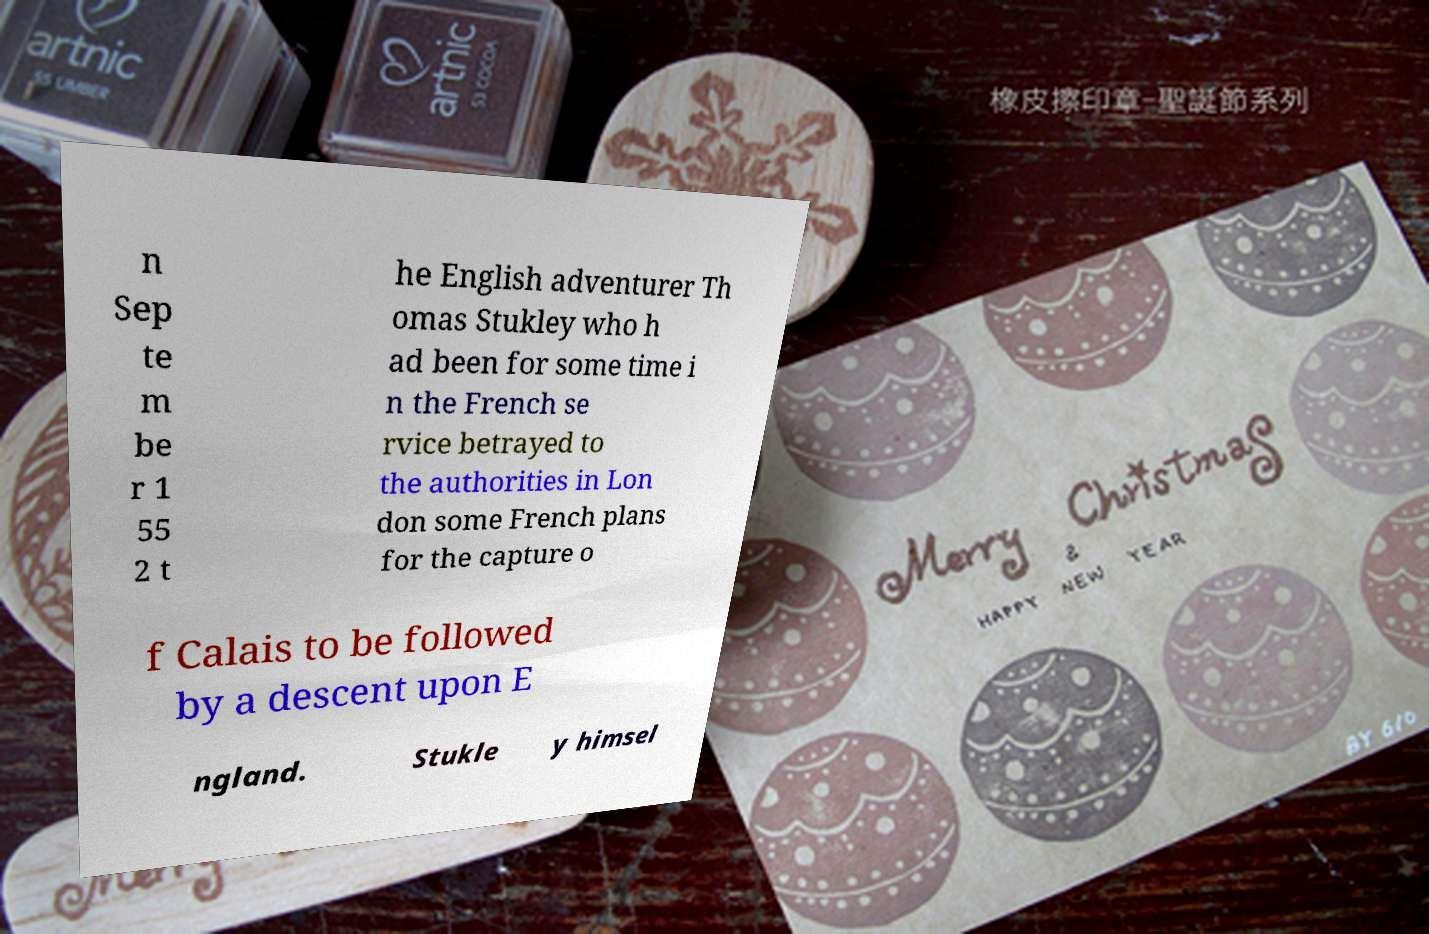Could you assist in decoding the text presented in this image and type it out clearly? n Sep te m be r 1 55 2 t he English adventurer Th omas Stukley who h ad been for some time i n the French se rvice betrayed to the authorities in Lon don some French plans for the capture o f Calais to be followed by a descent upon E ngland. Stukle y himsel 